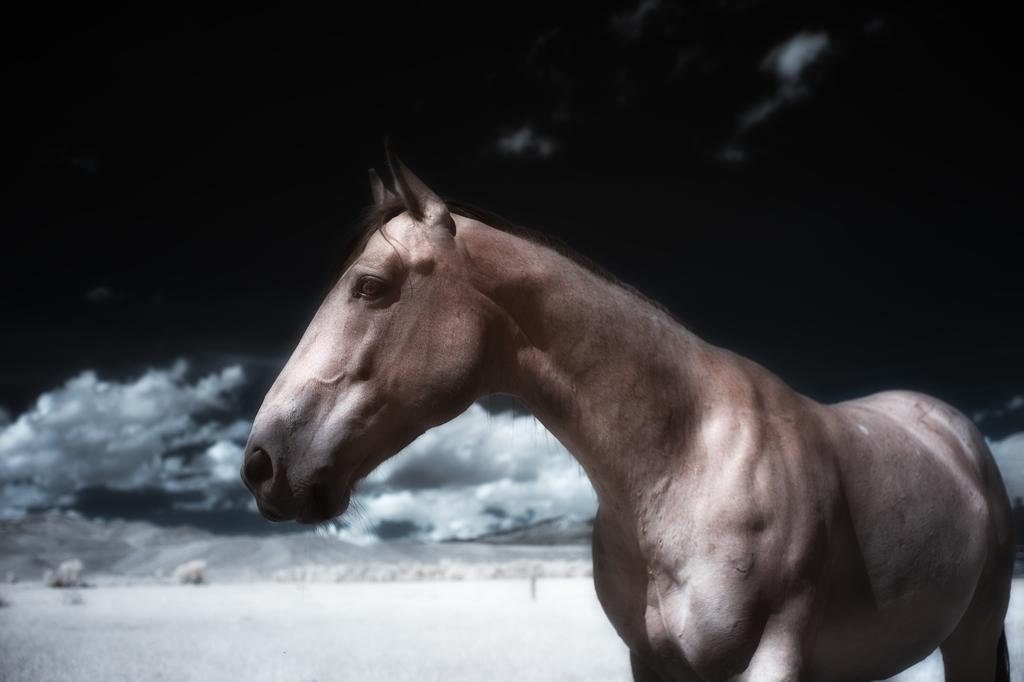What animal is present in the image? There is a horse in the image. How is the horse depicted in the image? The horse is truncated towards the bottom of the image. What is the condition of the ground in the image? There is ice on the ground in the image. What can be said about the lighting in the image? The background of the image is dark. Can you see the horse smiling in the image? There is no indication of the horse's facial expression in the image, so it cannot be determined if the horse is smiling. What type of cart is being pulled by the horse in the image? There is no cart present in the image; only the horse and the icy ground are visible. 